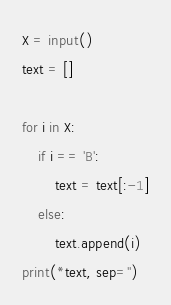<code> <loc_0><loc_0><loc_500><loc_500><_Python_>X = input()
text = []

for i in X:
    if i == 'B':
        text = text[:-1]
    else:
        text.append(i)
print(*text, sep='')</code> 